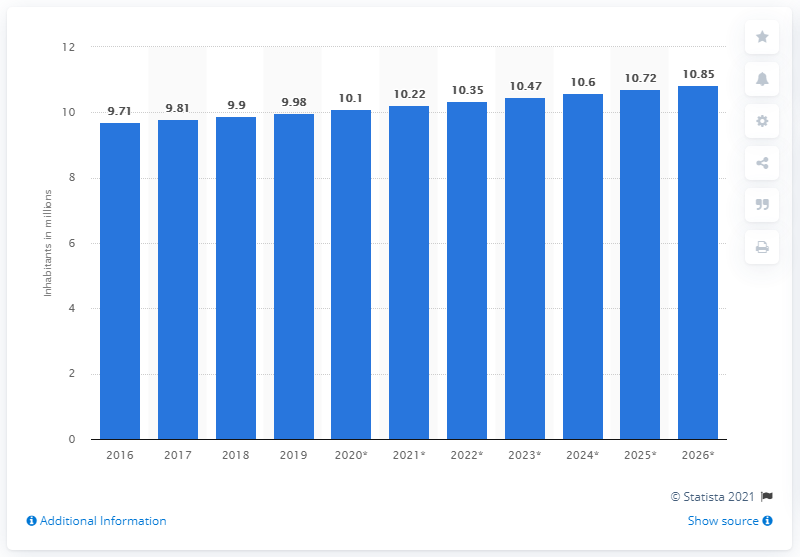List a handful of essential elements in this visual. The population of Azerbaijan in 2019 was 9,980,000. 